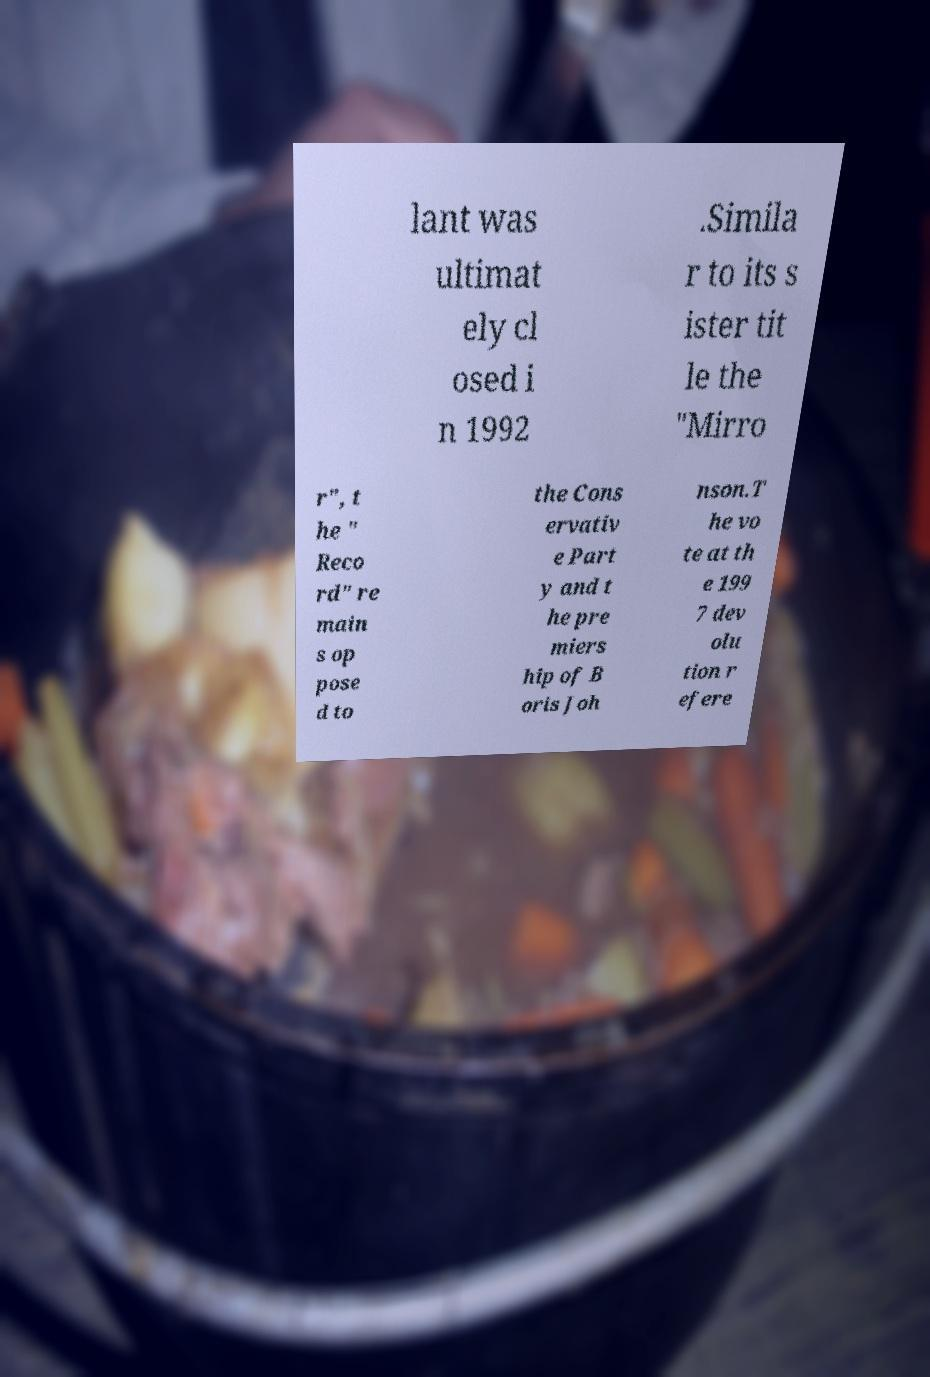I need the written content from this picture converted into text. Can you do that? lant was ultimat ely cl osed i n 1992 .Simila r to its s ister tit le the "Mirro r", t he " Reco rd" re main s op pose d to the Cons ervativ e Part y and t he pre miers hip of B oris Joh nson.T he vo te at th e 199 7 dev olu tion r efere 